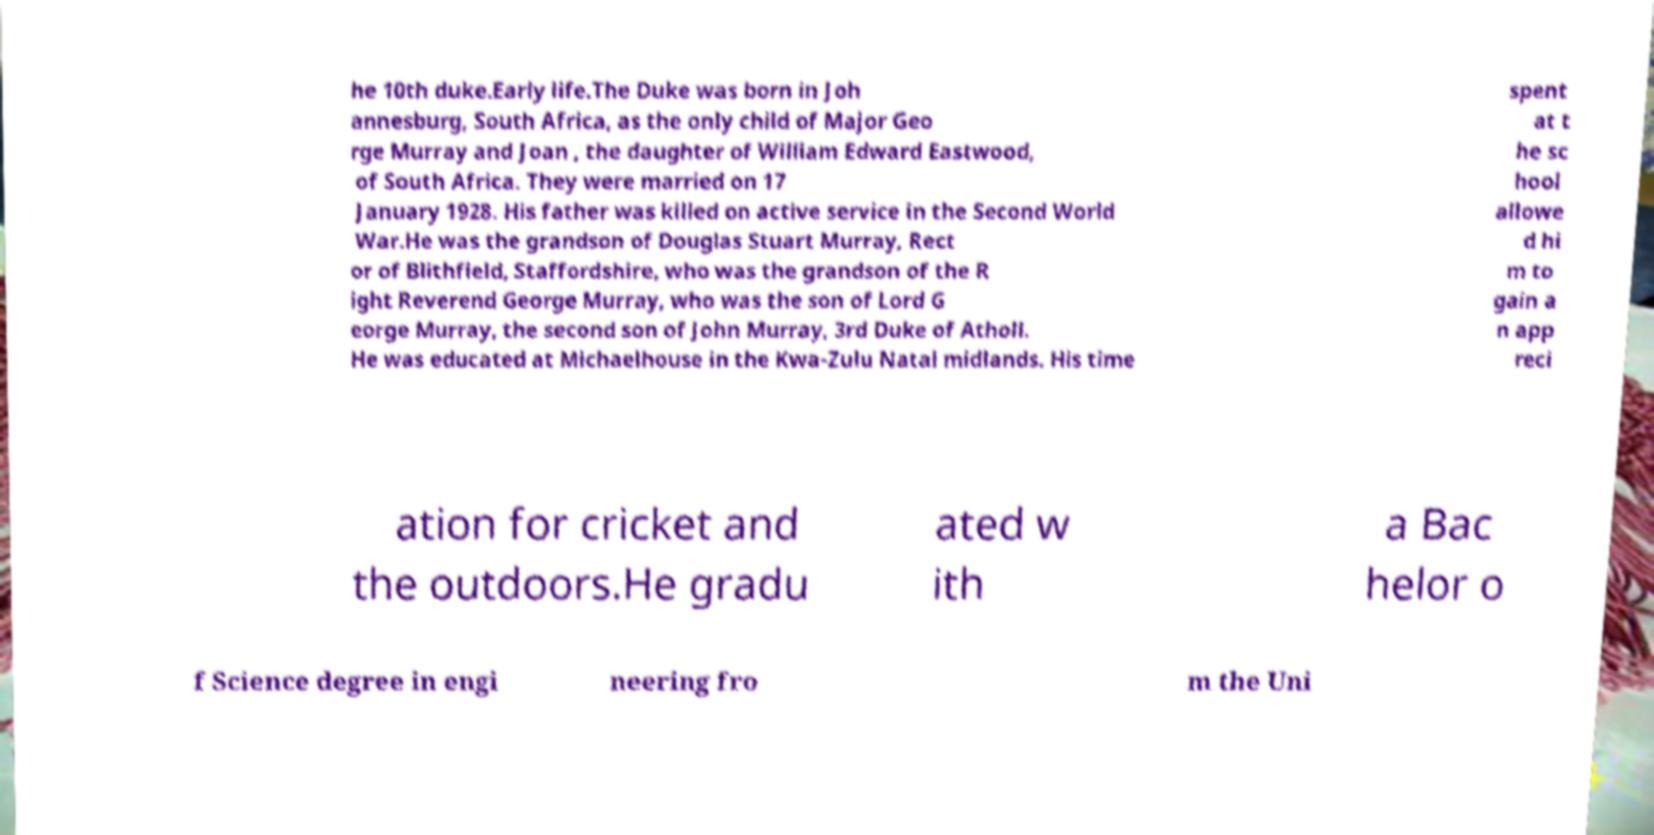I need the written content from this picture converted into text. Can you do that? he 10th duke.Early life.The Duke was born in Joh annesburg, South Africa, as the only child of Major Geo rge Murray and Joan , the daughter of William Edward Eastwood, of South Africa. They were married on 17 January 1928. His father was killed on active service in the Second World War.He was the grandson of Douglas Stuart Murray, Rect or of Blithfield, Staffordshire, who was the grandson of the R ight Reverend George Murray, who was the son of Lord G eorge Murray, the second son of John Murray, 3rd Duke of Atholl. He was educated at Michaelhouse in the Kwa-Zulu Natal midlands. His time spent at t he sc hool allowe d hi m to gain a n app reci ation for cricket and the outdoors.He gradu ated w ith a Bac helor o f Science degree in engi neering fro m the Uni 